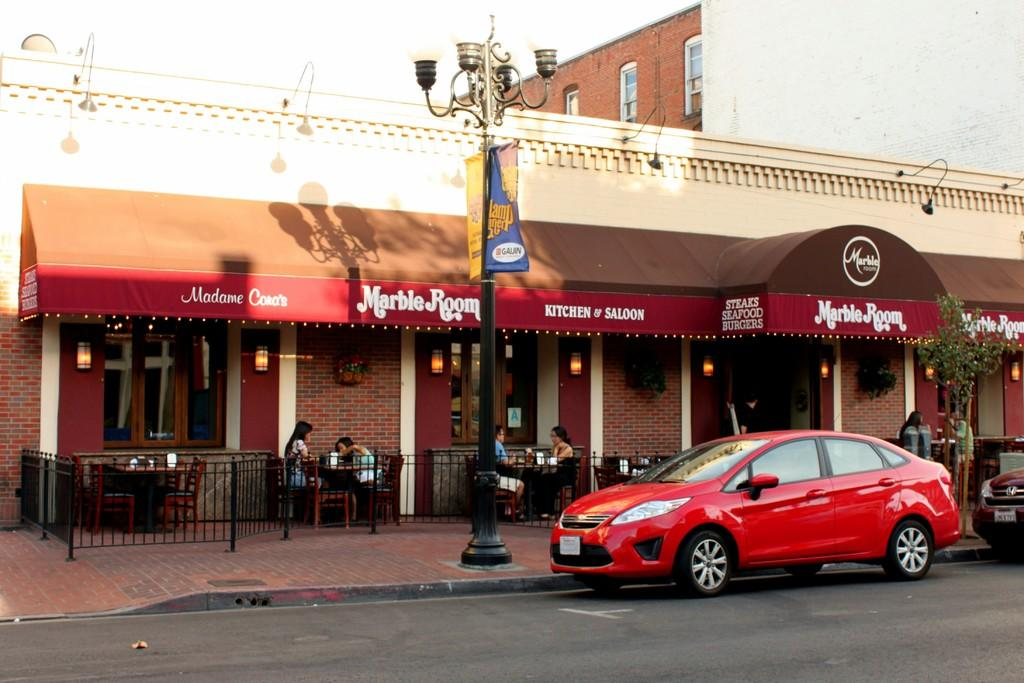What type of vehicles can be seen on the road in the image? There are cars on the road in the image. What type of furniture is present in the image? There are tables and chairs in the image. What type of illumination is visible in the image? There are lights in the image. What type of vegetation is present in the image? There are plants in the image. What type of signage is present in the image? There are boards in the image. Are there any people visible in the image? Yes, there are persons in the image. What type of barrier is present in the image? There is a fence in the image. What type of vertical structure is present in the image? There is a pole in the image. What type of promotional material is present in the image? There is a banner in the image. What type of background can be seen in the image? There is a building in the background of the image. What type of bait is being used to catch fish in the image? There is no fishing or bait present in the image. What type of sand can be seen on the beach in the image? There is no beach or sand present in the image. 